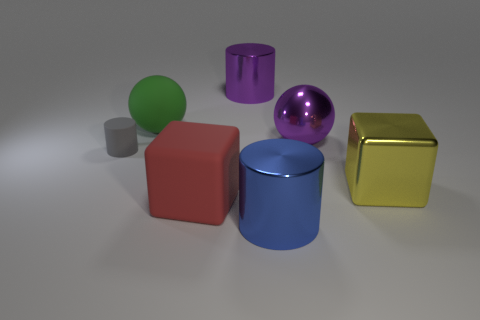Subtract all green cylinders. Subtract all red spheres. How many cylinders are left? 3 Add 2 large green matte balls. How many objects exist? 9 Subtract all spheres. How many objects are left? 5 Add 7 cylinders. How many cylinders exist? 10 Subtract 0 brown cubes. How many objects are left? 7 Subtract all tiny purple matte objects. Subtract all spheres. How many objects are left? 5 Add 1 metallic objects. How many metallic objects are left? 5 